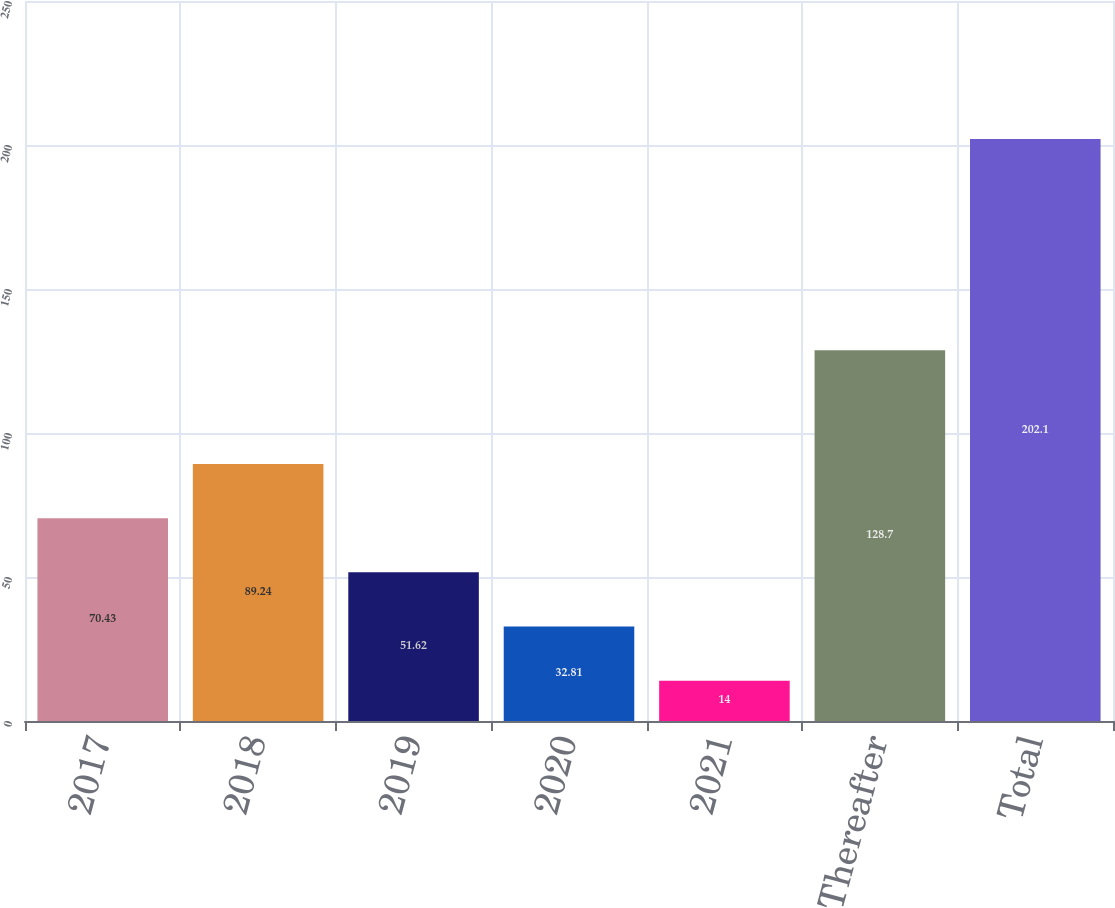Convert chart. <chart><loc_0><loc_0><loc_500><loc_500><bar_chart><fcel>2017<fcel>2018<fcel>2019<fcel>2020<fcel>2021<fcel>Thereafter<fcel>Total<nl><fcel>70.43<fcel>89.24<fcel>51.62<fcel>32.81<fcel>14<fcel>128.7<fcel>202.1<nl></chart> 